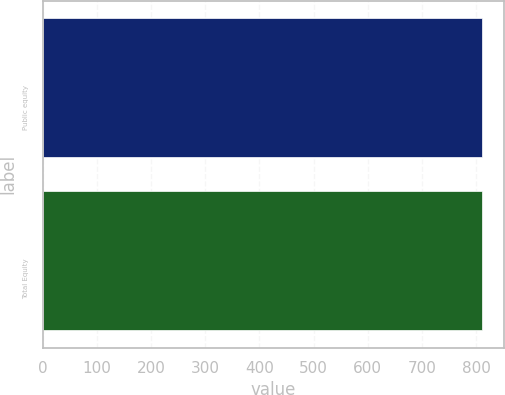Convert chart. <chart><loc_0><loc_0><loc_500><loc_500><bar_chart><fcel>Public equity<fcel>Total Equity<nl><fcel>811<fcel>811.1<nl></chart> 